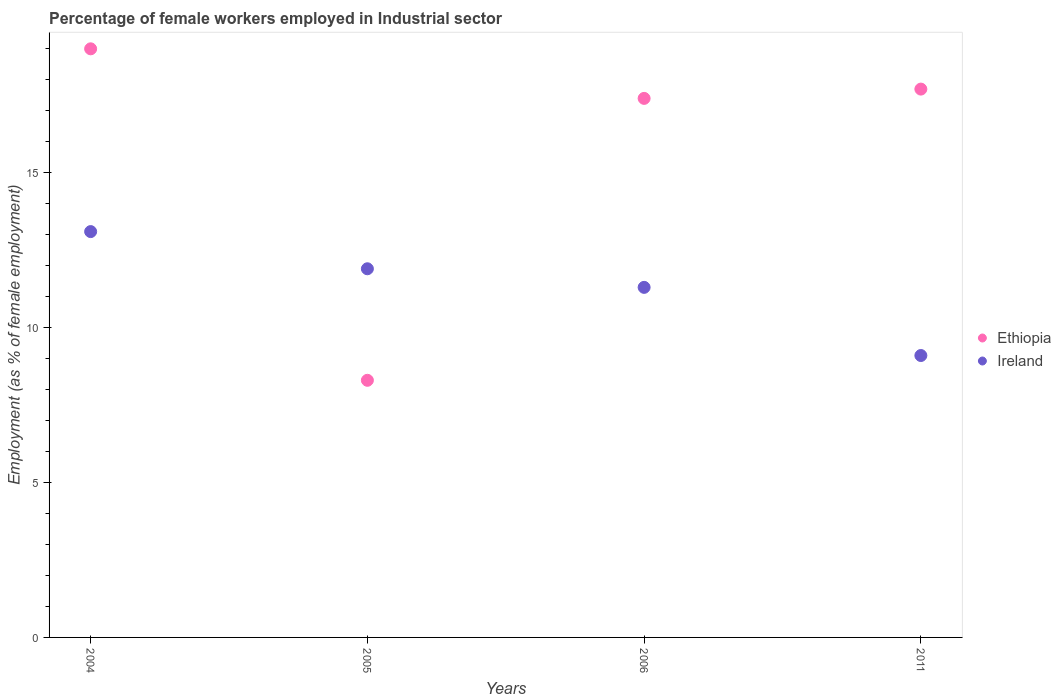What is the percentage of females employed in Industrial sector in Ethiopia in 2011?
Offer a very short reply. 17.7. Across all years, what is the maximum percentage of females employed in Industrial sector in Ethiopia?
Your answer should be very brief. 19. Across all years, what is the minimum percentage of females employed in Industrial sector in Ethiopia?
Keep it short and to the point. 8.3. What is the total percentage of females employed in Industrial sector in Ireland in the graph?
Provide a short and direct response. 45.4. What is the difference between the percentage of females employed in Industrial sector in Ireland in 2004 and that in 2005?
Offer a very short reply. 1.2. What is the difference between the percentage of females employed in Industrial sector in Ethiopia in 2004 and the percentage of females employed in Industrial sector in Ireland in 2005?
Offer a very short reply. 7.1. What is the average percentage of females employed in Industrial sector in Ireland per year?
Give a very brief answer. 11.35. In the year 2004, what is the difference between the percentage of females employed in Industrial sector in Ethiopia and percentage of females employed in Industrial sector in Ireland?
Your response must be concise. 5.9. What is the ratio of the percentage of females employed in Industrial sector in Ethiopia in 2004 to that in 2006?
Offer a terse response. 1.09. Is the percentage of females employed in Industrial sector in Ireland in 2005 less than that in 2011?
Make the answer very short. No. What is the difference between the highest and the second highest percentage of females employed in Industrial sector in Ireland?
Ensure brevity in your answer.  1.2. What is the difference between the highest and the lowest percentage of females employed in Industrial sector in Ireland?
Your answer should be compact. 4. Does the percentage of females employed in Industrial sector in Ireland monotonically increase over the years?
Provide a short and direct response. No. Is the percentage of females employed in Industrial sector in Ethiopia strictly greater than the percentage of females employed in Industrial sector in Ireland over the years?
Offer a very short reply. No. Is the percentage of females employed in Industrial sector in Ethiopia strictly less than the percentage of females employed in Industrial sector in Ireland over the years?
Your answer should be compact. No. How many dotlines are there?
Your response must be concise. 2. What is the difference between two consecutive major ticks on the Y-axis?
Your response must be concise. 5. Are the values on the major ticks of Y-axis written in scientific E-notation?
Your answer should be very brief. No. How many legend labels are there?
Your response must be concise. 2. How are the legend labels stacked?
Offer a very short reply. Vertical. What is the title of the graph?
Give a very brief answer. Percentage of female workers employed in Industrial sector. Does "Nicaragua" appear as one of the legend labels in the graph?
Your answer should be compact. No. What is the label or title of the X-axis?
Offer a terse response. Years. What is the label or title of the Y-axis?
Offer a terse response. Employment (as % of female employment). What is the Employment (as % of female employment) in Ethiopia in 2004?
Offer a very short reply. 19. What is the Employment (as % of female employment) of Ireland in 2004?
Provide a short and direct response. 13.1. What is the Employment (as % of female employment) in Ethiopia in 2005?
Offer a terse response. 8.3. What is the Employment (as % of female employment) of Ireland in 2005?
Provide a succinct answer. 11.9. What is the Employment (as % of female employment) of Ethiopia in 2006?
Offer a terse response. 17.4. What is the Employment (as % of female employment) of Ireland in 2006?
Offer a very short reply. 11.3. What is the Employment (as % of female employment) in Ethiopia in 2011?
Your answer should be very brief. 17.7. What is the Employment (as % of female employment) of Ireland in 2011?
Your answer should be very brief. 9.1. Across all years, what is the maximum Employment (as % of female employment) of Ireland?
Offer a terse response. 13.1. Across all years, what is the minimum Employment (as % of female employment) in Ethiopia?
Your answer should be compact. 8.3. Across all years, what is the minimum Employment (as % of female employment) in Ireland?
Your response must be concise. 9.1. What is the total Employment (as % of female employment) of Ethiopia in the graph?
Offer a very short reply. 62.4. What is the total Employment (as % of female employment) of Ireland in the graph?
Give a very brief answer. 45.4. What is the difference between the Employment (as % of female employment) of Ethiopia in 2004 and that in 2005?
Your answer should be very brief. 10.7. What is the difference between the Employment (as % of female employment) of Ireland in 2004 and that in 2005?
Keep it short and to the point. 1.2. What is the difference between the Employment (as % of female employment) of Ireland in 2004 and that in 2006?
Make the answer very short. 1.8. What is the difference between the Employment (as % of female employment) of Ireland in 2004 and that in 2011?
Keep it short and to the point. 4. What is the difference between the Employment (as % of female employment) of Ireland in 2005 and that in 2006?
Give a very brief answer. 0.6. What is the difference between the Employment (as % of female employment) of Ethiopia in 2005 and that in 2011?
Your answer should be very brief. -9.4. What is the difference between the Employment (as % of female employment) in Ethiopia in 2006 and that in 2011?
Keep it short and to the point. -0.3. What is the difference between the Employment (as % of female employment) of Ireland in 2006 and that in 2011?
Your answer should be compact. 2.2. What is the difference between the Employment (as % of female employment) of Ethiopia in 2004 and the Employment (as % of female employment) of Ireland in 2005?
Offer a very short reply. 7.1. What is the difference between the Employment (as % of female employment) in Ethiopia in 2004 and the Employment (as % of female employment) in Ireland in 2006?
Your answer should be very brief. 7.7. What is the difference between the Employment (as % of female employment) in Ethiopia in 2005 and the Employment (as % of female employment) in Ireland in 2006?
Offer a terse response. -3. What is the average Employment (as % of female employment) of Ethiopia per year?
Provide a short and direct response. 15.6. What is the average Employment (as % of female employment) in Ireland per year?
Your response must be concise. 11.35. In the year 2006, what is the difference between the Employment (as % of female employment) in Ethiopia and Employment (as % of female employment) in Ireland?
Make the answer very short. 6.1. What is the ratio of the Employment (as % of female employment) in Ethiopia in 2004 to that in 2005?
Your answer should be compact. 2.29. What is the ratio of the Employment (as % of female employment) of Ireland in 2004 to that in 2005?
Provide a succinct answer. 1.1. What is the ratio of the Employment (as % of female employment) of Ethiopia in 2004 to that in 2006?
Make the answer very short. 1.09. What is the ratio of the Employment (as % of female employment) in Ireland in 2004 to that in 2006?
Offer a very short reply. 1.16. What is the ratio of the Employment (as % of female employment) of Ethiopia in 2004 to that in 2011?
Make the answer very short. 1.07. What is the ratio of the Employment (as % of female employment) of Ireland in 2004 to that in 2011?
Provide a short and direct response. 1.44. What is the ratio of the Employment (as % of female employment) in Ethiopia in 2005 to that in 2006?
Provide a short and direct response. 0.48. What is the ratio of the Employment (as % of female employment) in Ireland in 2005 to that in 2006?
Your answer should be very brief. 1.05. What is the ratio of the Employment (as % of female employment) in Ethiopia in 2005 to that in 2011?
Provide a short and direct response. 0.47. What is the ratio of the Employment (as % of female employment) in Ireland in 2005 to that in 2011?
Provide a succinct answer. 1.31. What is the ratio of the Employment (as % of female employment) of Ethiopia in 2006 to that in 2011?
Offer a very short reply. 0.98. What is the ratio of the Employment (as % of female employment) in Ireland in 2006 to that in 2011?
Your response must be concise. 1.24. What is the difference between the highest and the second highest Employment (as % of female employment) in Ethiopia?
Offer a very short reply. 1.3. What is the difference between the highest and the second highest Employment (as % of female employment) of Ireland?
Your answer should be compact. 1.2. What is the difference between the highest and the lowest Employment (as % of female employment) in Ethiopia?
Keep it short and to the point. 10.7. 